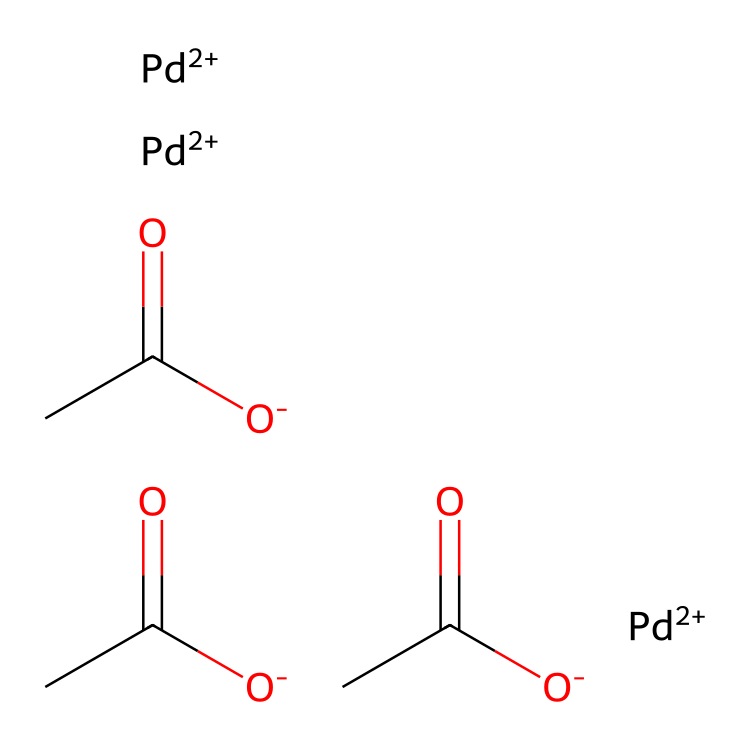What is the central metal ion in this coordination compound? The structure shows that there are three palladium ions depicted as "Pd+2" in the SMILES notation, which indicate that palladium is the central metal ion.
Answer: palladium How many acetate ligands are present in this compound? The SMILES shows "CC(=O)[O-]" repeated three times, indicating there are three acetate ligands coordinating to the palladium ions.
Answer: three What charge does the palladium metal carry in this complex? The SMILES includes "[Pd+2]", indicating that each palladium ion has a +2 oxidation state.
Answer: +2 What type of bonding occurs between the acetate ligands and the palladium ions? The acetate ligands exhibit coordinate covalent bonding, where the acetate donates a pair of electrons to the palladium metal, forming a complex.
Answer: coordinate covalent How many total atoms are in one palladium(II) acetate molecule? Counting from the SMILES, each acetate has 2 carbon, 2 oxygen, and 1 hydrogen (for three acetate groups) plus 3 palladium ions; the total is 3 × 4 atoms from acetates and 3 for palladium, equaling 15.
Answer: 15 What is the molecular arrangement of palladium(II) acetate in terms of coordination geometry? As a coordination compound, the arrangement suggests octahedral geometry because of the presence of multiple ligand attachments around the palladium center.
Answer: octahedral 